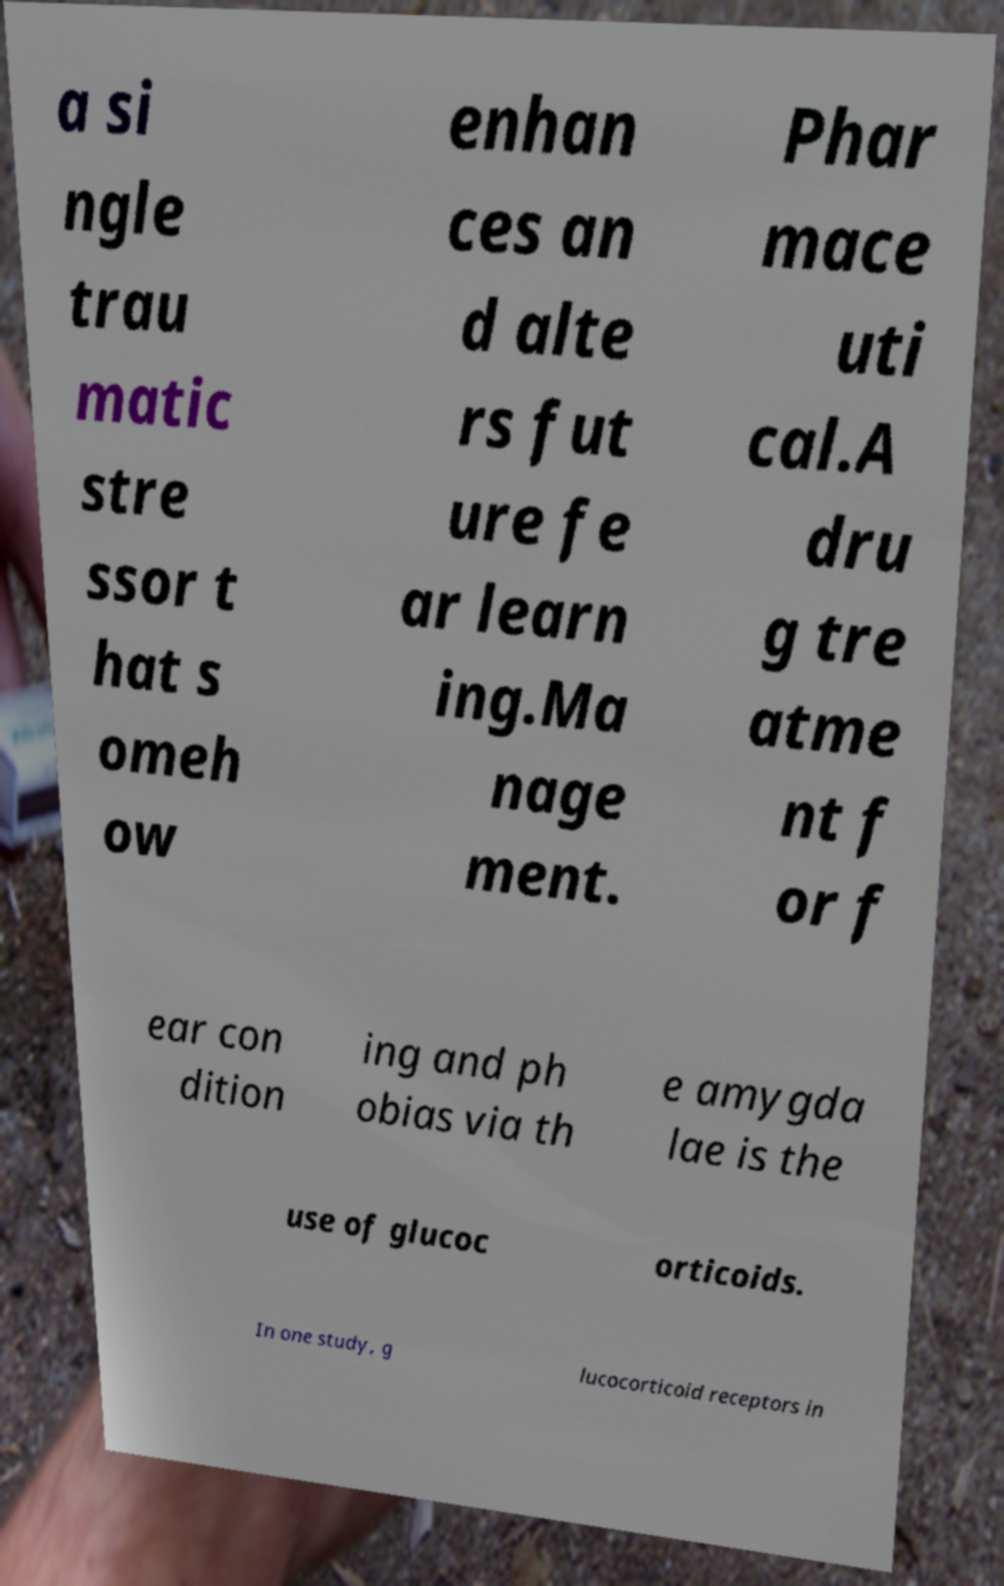Could you extract and type out the text from this image? a si ngle trau matic stre ssor t hat s omeh ow enhan ces an d alte rs fut ure fe ar learn ing.Ma nage ment. Phar mace uti cal.A dru g tre atme nt f or f ear con dition ing and ph obias via th e amygda lae is the use of glucoc orticoids. In one study, g lucocorticoid receptors in 